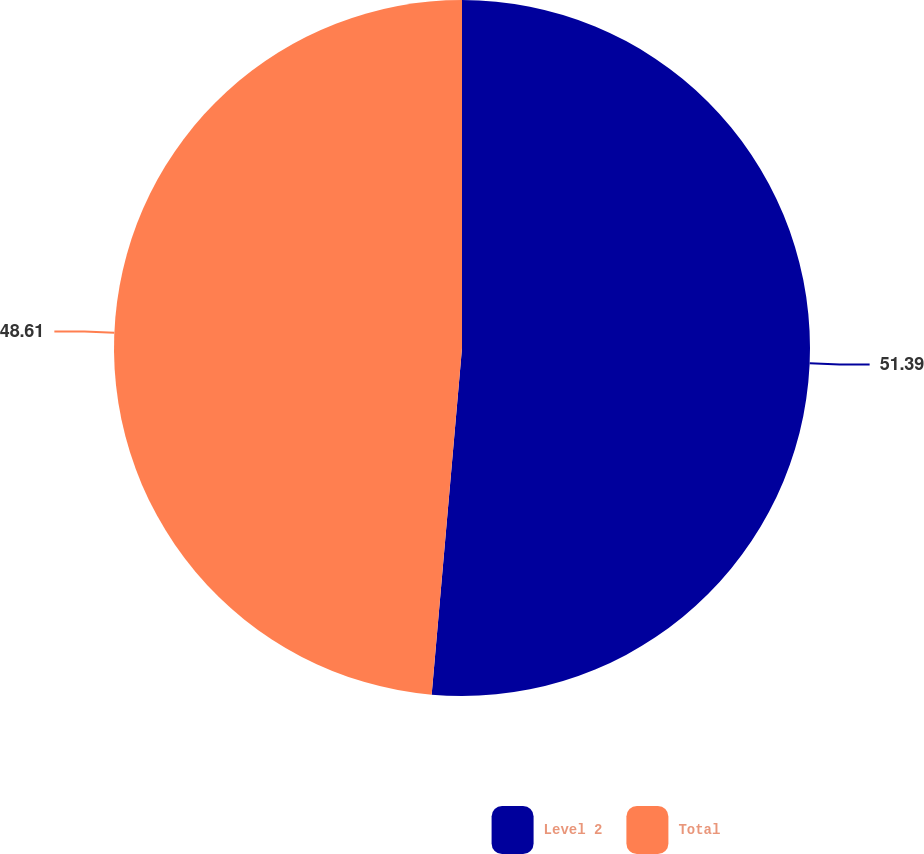Convert chart to OTSL. <chart><loc_0><loc_0><loc_500><loc_500><pie_chart><fcel>Level 2<fcel>Total<nl><fcel>51.39%<fcel>48.61%<nl></chart> 